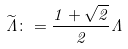<formula> <loc_0><loc_0><loc_500><loc_500>\widetilde { \Lambda } \colon = \frac { 1 + \sqrt { 2 } } { 2 } \Lambda</formula> 